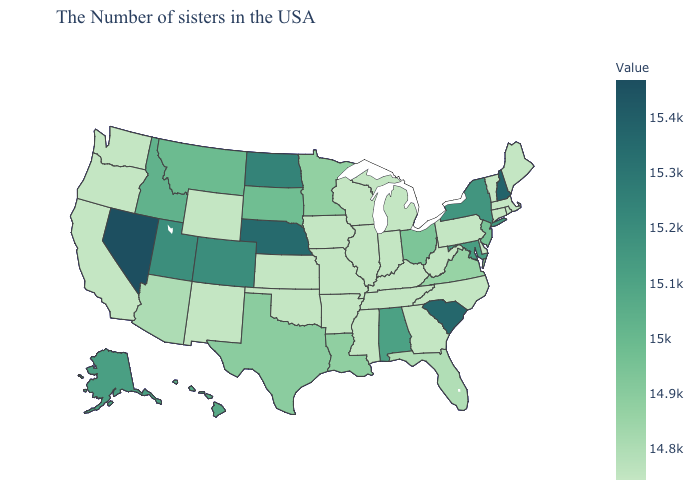Which states hav the highest value in the South?
Concise answer only. South Carolina. Which states have the lowest value in the West?
Quick response, please. Wyoming, New Mexico, California, Washington, Oregon. Does the map have missing data?
Concise answer only. No. Among the states that border Texas , which have the lowest value?
Give a very brief answer. Arkansas, Oklahoma, New Mexico. Does Nevada have the highest value in the USA?
Write a very short answer. Yes. Among the states that border Virginia , does Maryland have the lowest value?
Write a very short answer. No. Does New Hampshire have a higher value than Wyoming?
Short answer required. Yes. 